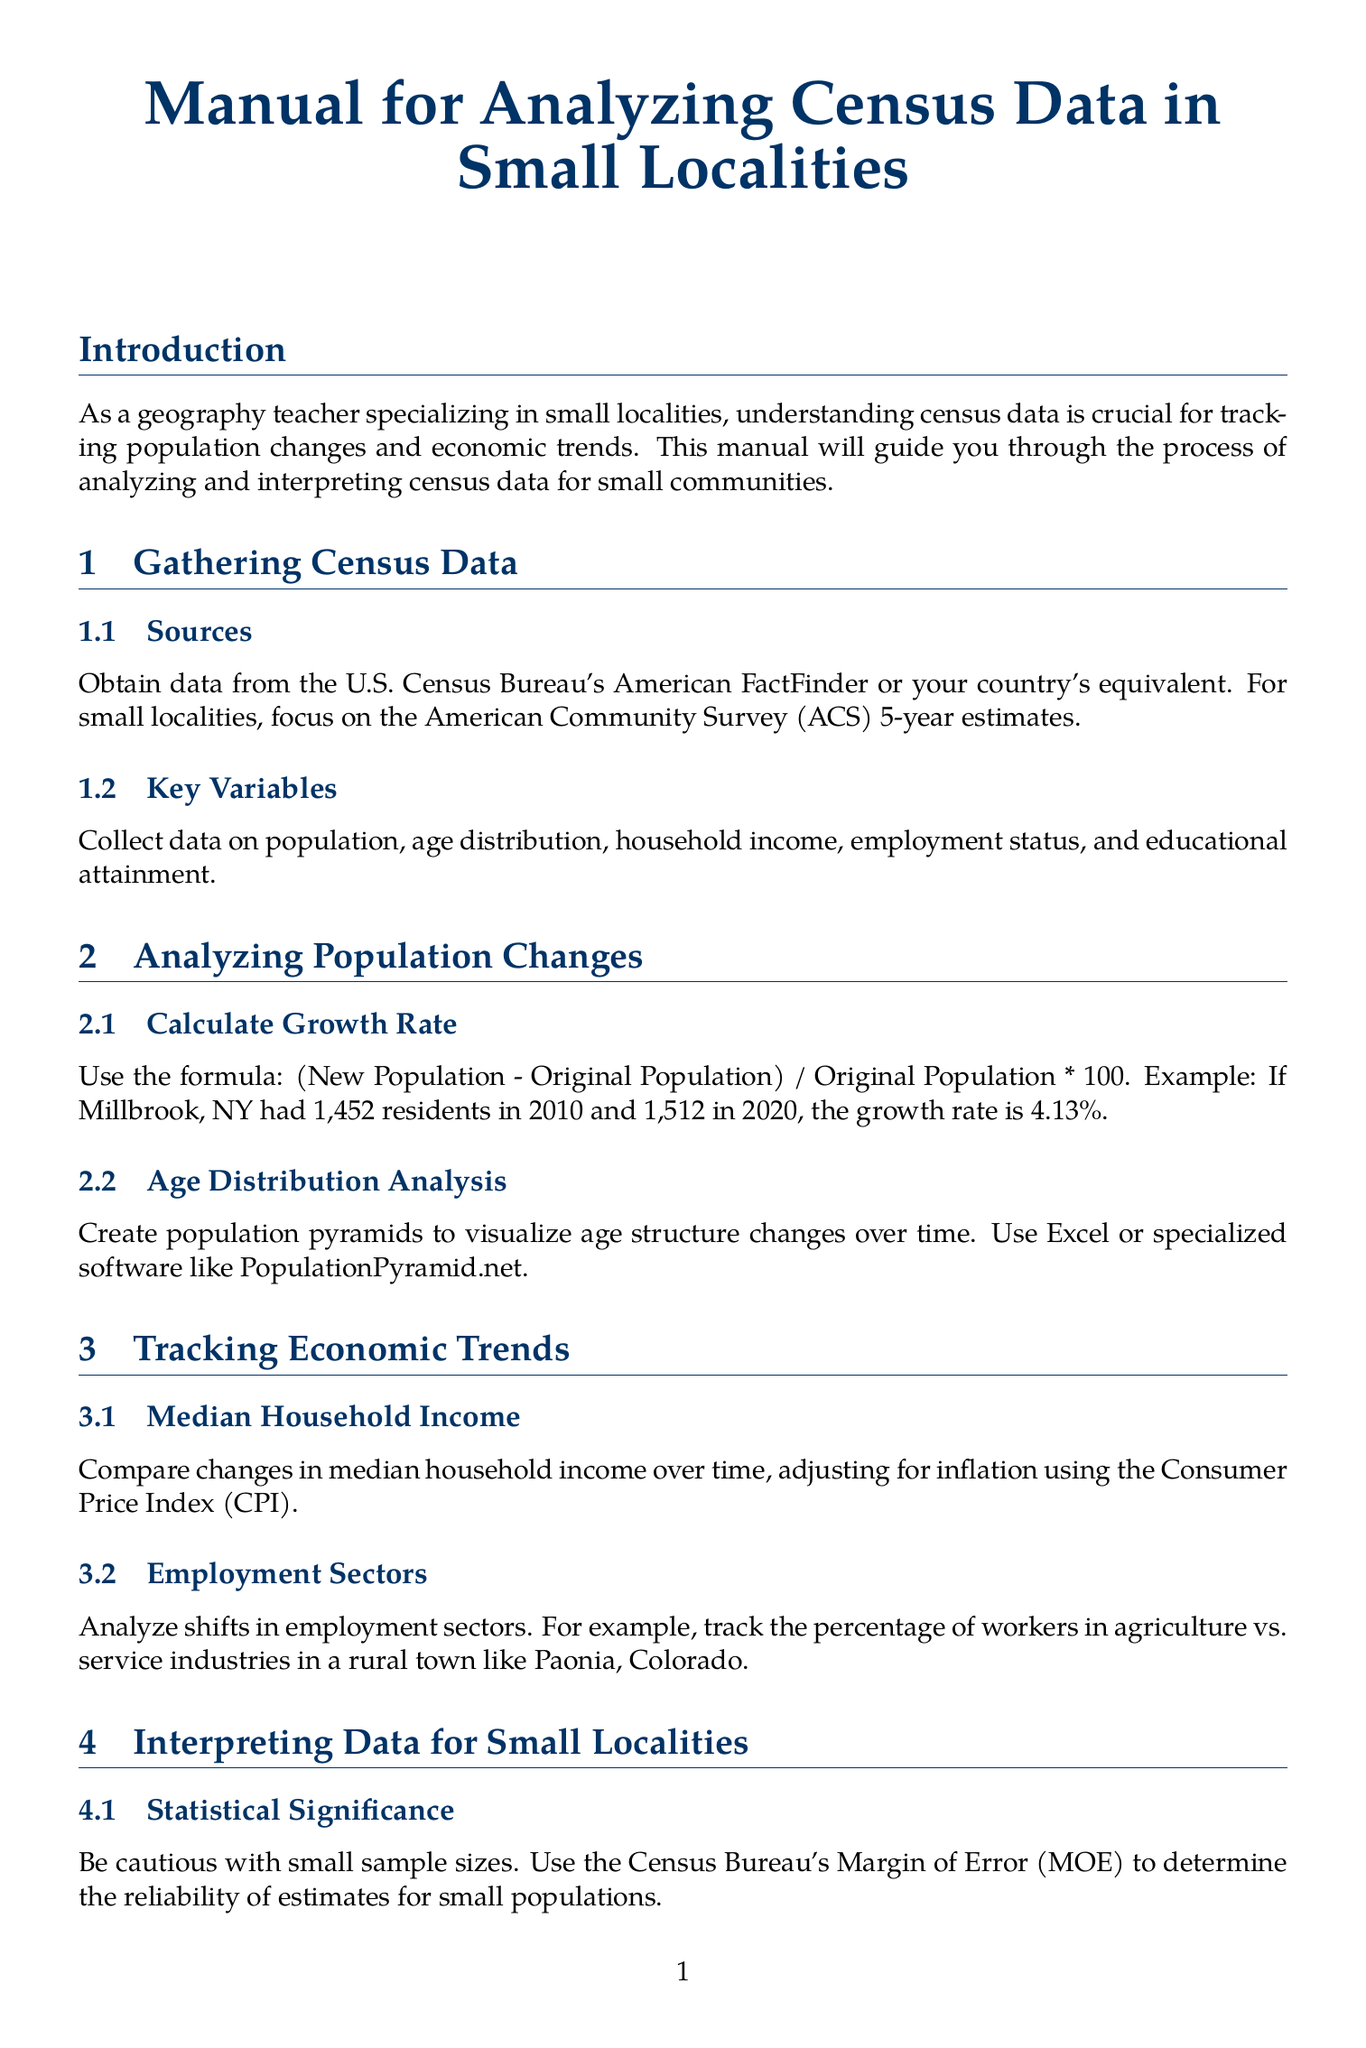What is the title of the manual? The title is explicitly stated at the beginning of the document.
Answer: Manual for Analyzing Census Data in Small Localities What year estimates should be focused on for small localities? The manual specifies a particular type of estimate appropriate for small localities within the data collection section.
Answer: American Community Survey (ACS) 5-year estimates What formula is used to calculate growth rate? The formula for growth rate is provided clearly within the content.
Answer: (New Population - Original Population) / Original Population * 100 What does the manual suggest for visualizing age structure changes? A specific visualization technique is recommended for analyzing age distribution.
Answer: Create population pyramids Which economic trend should be adjusted for inflation? One specific economic trend discussed in relation to inflation is highlighted in the economic trends section.
Answer: Median household income What type of software is recommended for creating choropleth maps? A type of software is provided in the section regarding visualization techniques.
Answer: GIS software like QGIS or ArcGIS What is emphasized at the conclusion of the manual? The conclusion summarizes the main point made regarding the analysis methodology.
Answer: Combining quantitative census data analysis with qualitative research What case study is mentioned in the manual? The document includes an example case study to illustrate its concepts.
Answer: North Adams, Massachusetts What should be used to gauge the reliability of estimates for small populations? A specific statistical measure is cited for assessing the reliability of census data estimates.
Answer: Margin of Error (MOE) 